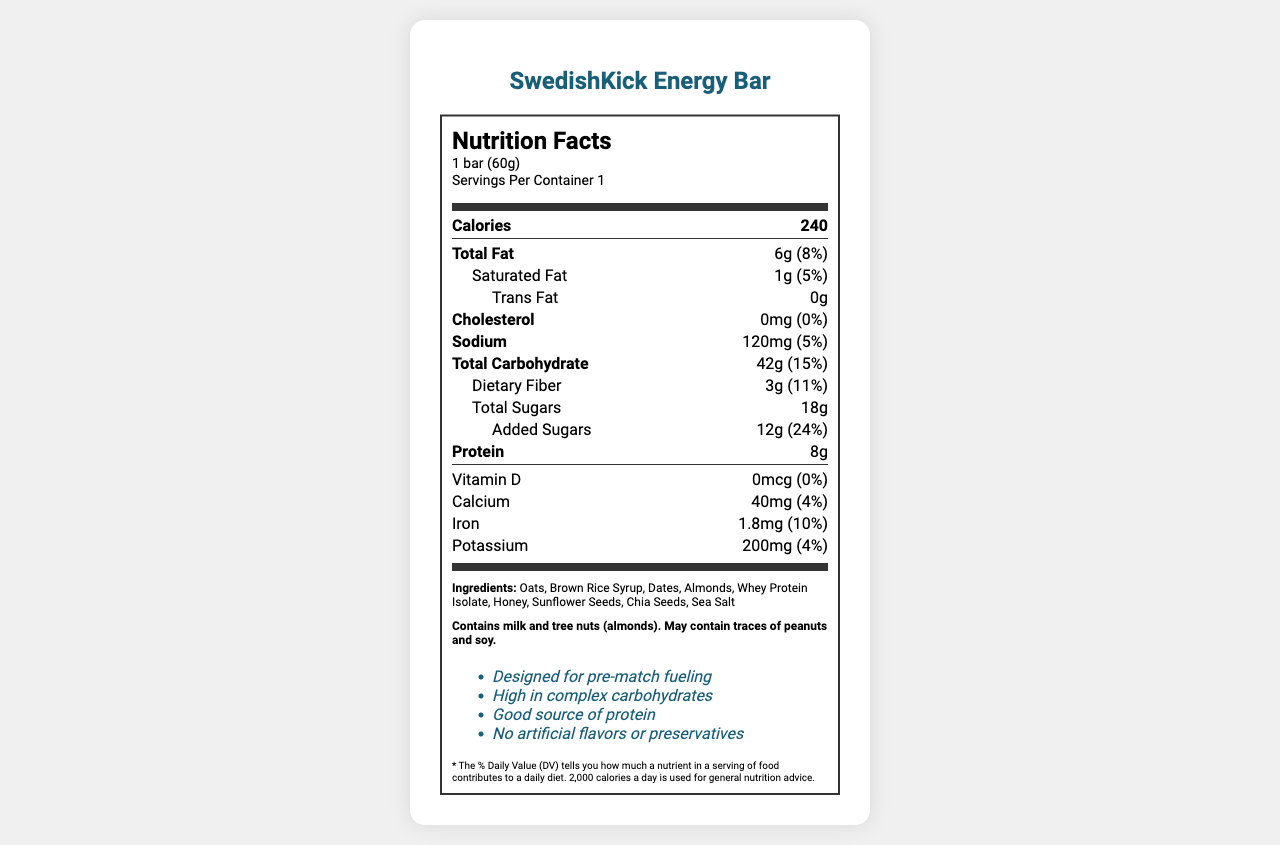who manufactures SwedishKick Energy Bar? The information about the manufacturer can be found at the bottom of the document under the manufacturer section.
Answer: Allsvenskan Nutrition AB, Gothenburg, Sweden what is the serving size for the energy bar? The serving size is listed at the top of the nutrition label in the serving information section.
Answer: 1 bar (60g) how many grams of total carbohydrates are in one serving? The total carbohydrate amount is listed in the nutrient information under "Total Carbohydrate."
Answer: 42g what percentage of the daily value for added sugars does the energy bar provide? The percentage daily value for added sugars is given next to the amount of added sugars in the nutrient information.
Answer: 24% list one of the claims made by the product. The claims are listed in the document towards the end and one of them is "Designed for pre-match fueling."
Answer: Designed for pre-match fueling how much protein does the SwedishKick Energy Bar contain? The amount of protein is listed in the nutrient information under "Protein."
Answer: 8g which of the following ingredients is not included in the SwedishKick Energy Bar? A. Oats B. Almonds C. Peanut Butter D. Honey The list of ingredients provided does not include Peanut Butter as one of the ingredients.
Answer: C. Peanut Butter what is the daily value percentage for calcium? A. 2% B. 4% C. 6% D. 8% The daily value percentage for calcium is listed as 4% in the vitamins section of the nutrient information.
Answer: B. 4% does the energy bar contain any artificial flavors or preservatives? One of the claims made by the product is "No artificial flavors or preservatives."
Answer: No summarize the main idea of the nutrition facts and claims of the SwedishKick Energy Bar. The nutrition label provides detailed information about the various nutrients and their amounts, while the claims highlight the purpose of the bar and its natural composition.
Answer: The SwedishKick Energy Bar is a carbohydrate-rich snack designed to fuel athletes before a match. It contains 240 calories per serving, with nutrients such as 42g of carbohydrates, 8g of protein, and various vitamins and minerals. It is free from artificial flavors and preservatives and is designed for optimal energy before a match. what is the recommended time to consume the energy bar before a match? The recommended use section specifically states to consume 1-2 hours before kickoff for optimal energy during the match.
Answer: 1-2 hours before kickoff is the energy bar suitable for someone with a peanut allergy? The allergen information section states that the bar may contain traces of peanuts.
Answer: No what are the sources of dietary fiber in the energy bar? The specific sources of dietary fiber are not explicitly mentioned in the document; only the amount is given.
Answer: Cannot be determined 